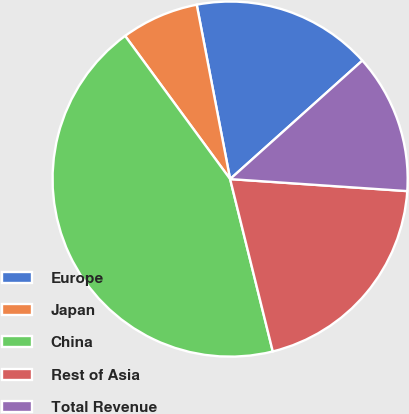Convert chart to OTSL. <chart><loc_0><loc_0><loc_500><loc_500><pie_chart><fcel>Europe<fcel>Japan<fcel>China<fcel>Rest of Asia<fcel>Total Revenue<nl><fcel>16.38%<fcel>7.06%<fcel>43.79%<fcel>20.06%<fcel>12.71%<nl></chart> 